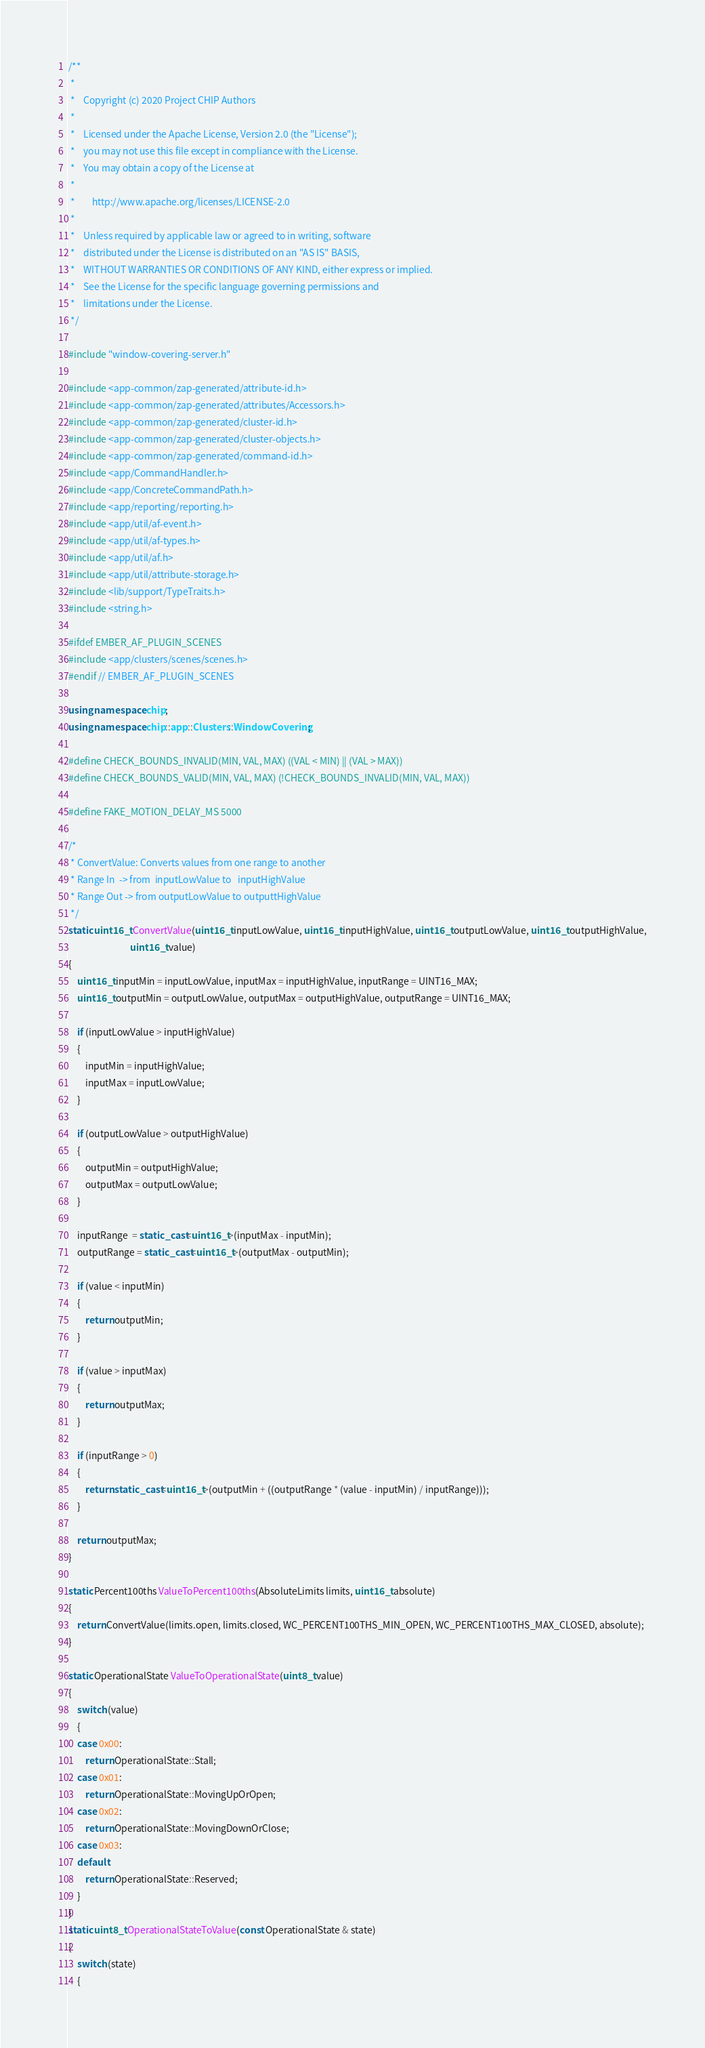<code> <loc_0><loc_0><loc_500><loc_500><_C++_>/**
 *
 *    Copyright (c) 2020 Project CHIP Authors
 *
 *    Licensed under the Apache License, Version 2.0 (the "License");
 *    you may not use this file except in compliance with the License.
 *    You may obtain a copy of the License at
 *
 *        http://www.apache.org/licenses/LICENSE-2.0
 *
 *    Unless required by applicable law or agreed to in writing, software
 *    distributed under the License is distributed on an "AS IS" BASIS,
 *    WITHOUT WARRANTIES OR CONDITIONS OF ANY KIND, either express or implied.
 *    See the License for the specific language governing permissions and
 *    limitations under the License.
 */

#include "window-covering-server.h"

#include <app-common/zap-generated/attribute-id.h>
#include <app-common/zap-generated/attributes/Accessors.h>
#include <app-common/zap-generated/cluster-id.h>
#include <app-common/zap-generated/cluster-objects.h>
#include <app-common/zap-generated/command-id.h>
#include <app/CommandHandler.h>
#include <app/ConcreteCommandPath.h>
#include <app/reporting/reporting.h>
#include <app/util/af-event.h>
#include <app/util/af-types.h>
#include <app/util/af.h>
#include <app/util/attribute-storage.h>
#include <lib/support/TypeTraits.h>
#include <string.h>

#ifdef EMBER_AF_PLUGIN_SCENES
#include <app/clusters/scenes/scenes.h>
#endif // EMBER_AF_PLUGIN_SCENES

using namespace chip;
using namespace chip::app::Clusters::WindowCovering;

#define CHECK_BOUNDS_INVALID(MIN, VAL, MAX) ((VAL < MIN) || (VAL > MAX))
#define CHECK_BOUNDS_VALID(MIN, VAL, MAX) (!CHECK_BOUNDS_INVALID(MIN, VAL, MAX))

#define FAKE_MOTION_DELAY_MS 5000

/*
 * ConvertValue: Converts values from one range to another
 * Range In  -> from  inputLowValue to   inputHighValue
 * Range Out -> from outputLowValue to outputtHighValue
 */
static uint16_t ConvertValue(uint16_t inputLowValue, uint16_t inputHighValue, uint16_t outputLowValue, uint16_t outputHighValue,
                             uint16_t value)
{
    uint16_t inputMin = inputLowValue, inputMax = inputHighValue, inputRange = UINT16_MAX;
    uint16_t outputMin = outputLowValue, outputMax = outputHighValue, outputRange = UINT16_MAX;

    if (inputLowValue > inputHighValue)
    {
        inputMin = inputHighValue;
        inputMax = inputLowValue;
    }

    if (outputLowValue > outputHighValue)
    {
        outputMin = outputHighValue;
        outputMax = outputLowValue;
    }

    inputRange  = static_cast<uint16_t>(inputMax - inputMin);
    outputRange = static_cast<uint16_t>(outputMax - outputMin);

    if (value < inputMin)
    {
        return outputMin;
    }

    if (value > inputMax)
    {
        return outputMax;
    }

    if (inputRange > 0)
    {
        return static_cast<uint16_t>(outputMin + ((outputRange * (value - inputMin) / inputRange)));
    }

    return outputMax;
}

static Percent100ths ValueToPercent100ths(AbsoluteLimits limits, uint16_t absolute)
{
    return ConvertValue(limits.open, limits.closed, WC_PERCENT100THS_MIN_OPEN, WC_PERCENT100THS_MAX_CLOSED, absolute);
}

static OperationalState ValueToOperationalState(uint8_t value)
{
    switch (value)
    {
    case 0x00:
        return OperationalState::Stall;
    case 0x01:
        return OperationalState::MovingUpOrOpen;
    case 0x02:
        return OperationalState::MovingDownOrClose;
    case 0x03:
    default:
        return OperationalState::Reserved;
    }
}
static uint8_t OperationalStateToValue(const OperationalState & state)
{
    switch (state)
    {</code> 